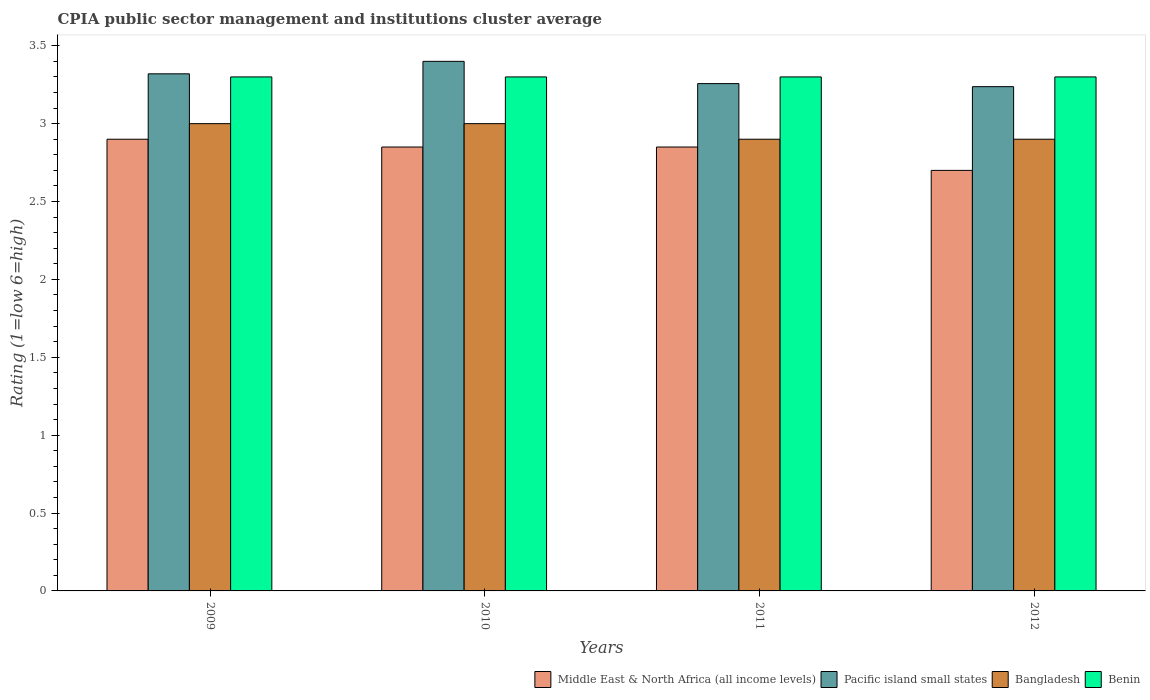How many different coloured bars are there?
Your answer should be compact. 4. How many groups of bars are there?
Your answer should be very brief. 4. Are the number of bars on each tick of the X-axis equal?
Ensure brevity in your answer.  Yes. In how many cases, is the number of bars for a given year not equal to the number of legend labels?
Your answer should be compact. 0. Across all years, what is the minimum CPIA rating in Middle East & North Africa (all income levels)?
Offer a very short reply. 2.7. In which year was the CPIA rating in Middle East & North Africa (all income levels) maximum?
Your answer should be compact. 2009. What is the difference between the CPIA rating in Bangladesh in 2009 and that in 2010?
Keep it short and to the point. 0. What is the difference between the CPIA rating in Bangladesh in 2010 and the CPIA rating in Pacific island small states in 2009?
Offer a very short reply. -0.32. What is the average CPIA rating in Benin per year?
Keep it short and to the point. 3.3. In the year 2011, what is the difference between the CPIA rating in Middle East & North Africa (all income levels) and CPIA rating in Benin?
Offer a very short reply. -0.45. In how many years, is the CPIA rating in Middle East & North Africa (all income levels) greater than 0.30000000000000004?
Provide a succinct answer. 4. What is the ratio of the CPIA rating in Pacific island small states in 2011 to that in 2012?
Make the answer very short. 1.01. What is the difference between the highest and the second highest CPIA rating in Pacific island small states?
Your response must be concise. 0.08. What is the difference between the highest and the lowest CPIA rating in Middle East & North Africa (all income levels)?
Ensure brevity in your answer.  0.2. Is the sum of the CPIA rating in Benin in 2010 and 2012 greater than the maximum CPIA rating in Pacific island small states across all years?
Offer a terse response. Yes. Is it the case that in every year, the sum of the CPIA rating in Benin and CPIA rating in Pacific island small states is greater than the sum of CPIA rating in Bangladesh and CPIA rating in Middle East & North Africa (all income levels)?
Provide a short and direct response. No. What does the 3rd bar from the left in 2009 represents?
Make the answer very short. Bangladesh. What does the 2nd bar from the right in 2011 represents?
Make the answer very short. Bangladesh. How many bars are there?
Your answer should be compact. 16. Are all the bars in the graph horizontal?
Your answer should be very brief. No. What is the difference between two consecutive major ticks on the Y-axis?
Make the answer very short. 0.5. Does the graph contain any zero values?
Offer a very short reply. No. Does the graph contain grids?
Make the answer very short. No. How many legend labels are there?
Your response must be concise. 4. What is the title of the graph?
Make the answer very short. CPIA public sector management and institutions cluster average. What is the Rating (1=low 6=high) in Middle East & North Africa (all income levels) in 2009?
Provide a short and direct response. 2.9. What is the Rating (1=low 6=high) of Pacific island small states in 2009?
Keep it short and to the point. 3.32. What is the Rating (1=low 6=high) in Bangladesh in 2009?
Keep it short and to the point. 3. What is the Rating (1=low 6=high) of Middle East & North Africa (all income levels) in 2010?
Offer a very short reply. 2.85. What is the Rating (1=low 6=high) in Pacific island small states in 2010?
Give a very brief answer. 3.4. What is the Rating (1=low 6=high) of Benin in 2010?
Provide a succinct answer. 3.3. What is the Rating (1=low 6=high) in Middle East & North Africa (all income levels) in 2011?
Offer a very short reply. 2.85. What is the Rating (1=low 6=high) of Pacific island small states in 2011?
Ensure brevity in your answer.  3.26. What is the Rating (1=low 6=high) of Benin in 2011?
Offer a very short reply. 3.3. What is the Rating (1=low 6=high) in Middle East & North Africa (all income levels) in 2012?
Provide a succinct answer. 2.7. What is the Rating (1=low 6=high) in Pacific island small states in 2012?
Make the answer very short. 3.24. What is the Rating (1=low 6=high) of Benin in 2012?
Your answer should be very brief. 3.3. Across all years, what is the maximum Rating (1=low 6=high) of Pacific island small states?
Offer a very short reply. 3.4. Across all years, what is the maximum Rating (1=low 6=high) of Benin?
Ensure brevity in your answer.  3.3. Across all years, what is the minimum Rating (1=low 6=high) of Middle East & North Africa (all income levels)?
Ensure brevity in your answer.  2.7. Across all years, what is the minimum Rating (1=low 6=high) of Pacific island small states?
Your response must be concise. 3.24. Across all years, what is the minimum Rating (1=low 6=high) in Bangladesh?
Your response must be concise. 2.9. What is the total Rating (1=low 6=high) of Middle East & North Africa (all income levels) in the graph?
Ensure brevity in your answer.  11.3. What is the total Rating (1=low 6=high) in Pacific island small states in the graph?
Provide a succinct answer. 13.21. What is the total Rating (1=low 6=high) of Bangladesh in the graph?
Offer a terse response. 11.8. What is the total Rating (1=low 6=high) of Benin in the graph?
Your answer should be compact. 13.2. What is the difference between the Rating (1=low 6=high) in Middle East & North Africa (all income levels) in 2009 and that in 2010?
Provide a succinct answer. 0.05. What is the difference between the Rating (1=low 6=high) of Pacific island small states in 2009 and that in 2010?
Your response must be concise. -0.08. What is the difference between the Rating (1=low 6=high) in Benin in 2009 and that in 2010?
Provide a succinct answer. 0. What is the difference between the Rating (1=low 6=high) of Middle East & North Africa (all income levels) in 2009 and that in 2011?
Ensure brevity in your answer.  0.05. What is the difference between the Rating (1=low 6=high) of Pacific island small states in 2009 and that in 2011?
Your answer should be very brief. 0.06. What is the difference between the Rating (1=low 6=high) in Benin in 2009 and that in 2011?
Make the answer very short. 0. What is the difference between the Rating (1=low 6=high) in Middle East & North Africa (all income levels) in 2009 and that in 2012?
Ensure brevity in your answer.  0.2. What is the difference between the Rating (1=low 6=high) in Pacific island small states in 2009 and that in 2012?
Your answer should be compact. 0.08. What is the difference between the Rating (1=low 6=high) of Bangladesh in 2009 and that in 2012?
Provide a short and direct response. 0.1. What is the difference between the Rating (1=low 6=high) in Middle East & North Africa (all income levels) in 2010 and that in 2011?
Offer a terse response. 0. What is the difference between the Rating (1=low 6=high) of Pacific island small states in 2010 and that in 2011?
Give a very brief answer. 0.14. What is the difference between the Rating (1=low 6=high) of Bangladesh in 2010 and that in 2011?
Make the answer very short. 0.1. What is the difference between the Rating (1=low 6=high) in Middle East & North Africa (all income levels) in 2010 and that in 2012?
Your response must be concise. 0.15. What is the difference between the Rating (1=low 6=high) in Pacific island small states in 2010 and that in 2012?
Provide a succinct answer. 0.16. What is the difference between the Rating (1=low 6=high) in Bangladesh in 2010 and that in 2012?
Give a very brief answer. 0.1. What is the difference between the Rating (1=low 6=high) of Benin in 2010 and that in 2012?
Offer a terse response. 0. What is the difference between the Rating (1=low 6=high) of Pacific island small states in 2011 and that in 2012?
Provide a short and direct response. 0.02. What is the difference between the Rating (1=low 6=high) of Bangladesh in 2011 and that in 2012?
Give a very brief answer. 0. What is the difference between the Rating (1=low 6=high) of Benin in 2011 and that in 2012?
Make the answer very short. 0. What is the difference between the Rating (1=low 6=high) in Middle East & North Africa (all income levels) in 2009 and the Rating (1=low 6=high) in Bangladesh in 2010?
Make the answer very short. -0.1. What is the difference between the Rating (1=low 6=high) of Middle East & North Africa (all income levels) in 2009 and the Rating (1=low 6=high) of Benin in 2010?
Make the answer very short. -0.4. What is the difference between the Rating (1=low 6=high) in Pacific island small states in 2009 and the Rating (1=low 6=high) in Bangladesh in 2010?
Offer a very short reply. 0.32. What is the difference between the Rating (1=low 6=high) in Middle East & North Africa (all income levels) in 2009 and the Rating (1=low 6=high) in Pacific island small states in 2011?
Your answer should be compact. -0.36. What is the difference between the Rating (1=low 6=high) of Middle East & North Africa (all income levels) in 2009 and the Rating (1=low 6=high) of Bangladesh in 2011?
Provide a short and direct response. 0. What is the difference between the Rating (1=low 6=high) of Pacific island small states in 2009 and the Rating (1=low 6=high) of Bangladesh in 2011?
Provide a succinct answer. 0.42. What is the difference between the Rating (1=low 6=high) of Middle East & North Africa (all income levels) in 2009 and the Rating (1=low 6=high) of Pacific island small states in 2012?
Provide a succinct answer. -0.34. What is the difference between the Rating (1=low 6=high) of Middle East & North Africa (all income levels) in 2009 and the Rating (1=low 6=high) of Benin in 2012?
Your answer should be very brief. -0.4. What is the difference between the Rating (1=low 6=high) in Pacific island small states in 2009 and the Rating (1=low 6=high) in Bangladesh in 2012?
Offer a terse response. 0.42. What is the difference between the Rating (1=low 6=high) of Bangladesh in 2009 and the Rating (1=low 6=high) of Benin in 2012?
Provide a short and direct response. -0.3. What is the difference between the Rating (1=low 6=high) in Middle East & North Africa (all income levels) in 2010 and the Rating (1=low 6=high) in Pacific island small states in 2011?
Give a very brief answer. -0.41. What is the difference between the Rating (1=low 6=high) in Middle East & North Africa (all income levels) in 2010 and the Rating (1=low 6=high) in Bangladesh in 2011?
Keep it short and to the point. -0.05. What is the difference between the Rating (1=low 6=high) in Middle East & North Africa (all income levels) in 2010 and the Rating (1=low 6=high) in Benin in 2011?
Provide a short and direct response. -0.45. What is the difference between the Rating (1=low 6=high) in Pacific island small states in 2010 and the Rating (1=low 6=high) in Benin in 2011?
Offer a very short reply. 0.1. What is the difference between the Rating (1=low 6=high) in Middle East & North Africa (all income levels) in 2010 and the Rating (1=low 6=high) in Pacific island small states in 2012?
Your response must be concise. -0.39. What is the difference between the Rating (1=low 6=high) in Middle East & North Africa (all income levels) in 2010 and the Rating (1=low 6=high) in Bangladesh in 2012?
Make the answer very short. -0.05. What is the difference between the Rating (1=low 6=high) in Middle East & North Africa (all income levels) in 2010 and the Rating (1=low 6=high) in Benin in 2012?
Your response must be concise. -0.45. What is the difference between the Rating (1=low 6=high) of Pacific island small states in 2010 and the Rating (1=low 6=high) of Bangladesh in 2012?
Offer a terse response. 0.5. What is the difference between the Rating (1=low 6=high) in Pacific island small states in 2010 and the Rating (1=low 6=high) in Benin in 2012?
Your response must be concise. 0.1. What is the difference between the Rating (1=low 6=high) of Bangladesh in 2010 and the Rating (1=low 6=high) of Benin in 2012?
Your answer should be compact. -0.3. What is the difference between the Rating (1=low 6=high) in Middle East & North Africa (all income levels) in 2011 and the Rating (1=low 6=high) in Pacific island small states in 2012?
Your answer should be very brief. -0.39. What is the difference between the Rating (1=low 6=high) in Middle East & North Africa (all income levels) in 2011 and the Rating (1=low 6=high) in Benin in 2012?
Keep it short and to the point. -0.45. What is the difference between the Rating (1=low 6=high) in Pacific island small states in 2011 and the Rating (1=low 6=high) in Bangladesh in 2012?
Provide a succinct answer. 0.36. What is the difference between the Rating (1=low 6=high) in Pacific island small states in 2011 and the Rating (1=low 6=high) in Benin in 2012?
Your answer should be compact. -0.04. What is the difference between the Rating (1=low 6=high) of Bangladesh in 2011 and the Rating (1=low 6=high) of Benin in 2012?
Give a very brief answer. -0.4. What is the average Rating (1=low 6=high) of Middle East & North Africa (all income levels) per year?
Make the answer very short. 2.83. What is the average Rating (1=low 6=high) in Pacific island small states per year?
Ensure brevity in your answer.  3.3. What is the average Rating (1=low 6=high) in Bangladesh per year?
Ensure brevity in your answer.  2.95. In the year 2009, what is the difference between the Rating (1=low 6=high) of Middle East & North Africa (all income levels) and Rating (1=low 6=high) of Pacific island small states?
Your answer should be compact. -0.42. In the year 2009, what is the difference between the Rating (1=low 6=high) in Middle East & North Africa (all income levels) and Rating (1=low 6=high) in Bangladesh?
Provide a short and direct response. -0.1. In the year 2009, what is the difference between the Rating (1=low 6=high) in Pacific island small states and Rating (1=low 6=high) in Bangladesh?
Your answer should be very brief. 0.32. In the year 2009, what is the difference between the Rating (1=low 6=high) of Bangladesh and Rating (1=low 6=high) of Benin?
Make the answer very short. -0.3. In the year 2010, what is the difference between the Rating (1=low 6=high) of Middle East & North Africa (all income levels) and Rating (1=low 6=high) of Pacific island small states?
Your response must be concise. -0.55. In the year 2010, what is the difference between the Rating (1=low 6=high) in Middle East & North Africa (all income levels) and Rating (1=low 6=high) in Bangladesh?
Your answer should be very brief. -0.15. In the year 2010, what is the difference between the Rating (1=low 6=high) of Middle East & North Africa (all income levels) and Rating (1=low 6=high) of Benin?
Ensure brevity in your answer.  -0.45. In the year 2010, what is the difference between the Rating (1=low 6=high) in Pacific island small states and Rating (1=low 6=high) in Benin?
Offer a terse response. 0.1. In the year 2010, what is the difference between the Rating (1=low 6=high) of Bangladesh and Rating (1=low 6=high) of Benin?
Make the answer very short. -0.3. In the year 2011, what is the difference between the Rating (1=low 6=high) of Middle East & North Africa (all income levels) and Rating (1=low 6=high) of Pacific island small states?
Make the answer very short. -0.41. In the year 2011, what is the difference between the Rating (1=low 6=high) in Middle East & North Africa (all income levels) and Rating (1=low 6=high) in Bangladesh?
Ensure brevity in your answer.  -0.05. In the year 2011, what is the difference between the Rating (1=low 6=high) in Middle East & North Africa (all income levels) and Rating (1=low 6=high) in Benin?
Your answer should be very brief. -0.45. In the year 2011, what is the difference between the Rating (1=low 6=high) in Pacific island small states and Rating (1=low 6=high) in Bangladesh?
Ensure brevity in your answer.  0.36. In the year 2011, what is the difference between the Rating (1=low 6=high) in Pacific island small states and Rating (1=low 6=high) in Benin?
Your answer should be compact. -0.04. In the year 2012, what is the difference between the Rating (1=low 6=high) in Middle East & North Africa (all income levels) and Rating (1=low 6=high) in Pacific island small states?
Your response must be concise. -0.54. In the year 2012, what is the difference between the Rating (1=low 6=high) of Middle East & North Africa (all income levels) and Rating (1=low 6=high) of Bangladesh?
Give a very brief answer. -0.2. In the year 2012, what is the difference between the Rating (1=low 6=high) of Pacific island small states and Rating (1=low 6=high) of Bangladesh?
Provide a short and direct response. 0.34. In the year 2012, what is the difference between the Rating (1=low 6=high) in Pacific island small states and Rating (1=low 6=high) in Benin?
Your answer should be very brief. -0.06. What is the ratio of the Rating (1=low 6=high) of Middle East & North Africa (all income levels) in 2009 to that in 2010?
Make the answer very short. 1.02. What is the ratio of the Rating (1=low 6=high) in Pacific island small states in 2009 to that in 2010?
Make the answer very short. 0.98. What is the ratio of the Rating (1=low 6=high) in Middle East & North Africa (all income levels) in 2009 to that in 2011?
Your answer should be very brief. 1.02. What is the ratio of the Rating (1=low 6=high) of Pacific island small states in 2009 to that in 2011?
Keep it short and to the point. 1.02. What is the ratio of the Rating (1=low 6=high) of Bangladesh in 2009 to that in 2011?
Offer a very short reply. 1.03. What is the ratio of the Rating (1=low 6=high) in Benin in 2009 to that in 2011?
Offer a terse response. 1. What is the ratio of the Rating (1=low 6=high) in Middle East & North Africa (all income levels) in 2009 to that in 2012?
Your response must be concise. 1.07. What is the ratio of the Rating (1=low 6=high) in Pacific island small states in 2009 to that in 2012?
Offer a very short reply. 1.03. What is the ratio of the Rating (1=low 6=high) of Bangladesh in 2009 to that in 2012?
Your answer should be very brief. 1.03. What is the ratio of the Rating (1=low 6=high) of Benin in 2009 to that in 2012?
Give a very brief answer. 1. What is the ratio of the Rating (1=low 6=high) of Middle East & North Africa (all income levels) in 2010 to that in 2011?
Provide a succinct answer. 1. What is the ratio of the Rating (1=low 6=high) of Pacific island small states in 2010 to that in 2011?
Make the answer very short. 1.04. What is the ratio of the Rating (1=low 6=high) in Bangladesh in 2010 to that in 2011?
Offer a very short reply. 1.03. What is the ratio of the Rating (1=low 6=high) of Benin in 2010 to that in 2011?
Your answer should be compact. 1. What is the ratio of the Rating (1=low 6=high) of Middle East & North Africa (all income levels) in 2010 to that in 2012?
Give a very brief answer. 1.06. What is the ratio of the Rating (1=low 6=high) of Pacific island small states in 2010 to that in 2012?
Your answer should be compact. 1.05. What is the ratio of the Rating (1=low 6=high) in Bangladesh in 2010 to that in 2012?
Make the answer very short. 1.03. What is the ratio of the Rating (1=low 6=high) in Middle East & North Africa (all income levels) in 2011 to that in 2012?
Your response must be concise. 1.06. What is the ratio of the Rating (1=low 6=high) in Pacific island small states in 2011 to that in 2012?
Your response must be concise. 1.01. What is the ratio of the Rating (1=low 6=high) in Bangladesh in 2011 to that in 2012?
Make the answer very short. 1. What is the ratio of the Rating (1=low 6=high) in Benin in 2011 to that in 2012?
Provide a succinct answer. 1. What is the difference between the highest and the second highest Rating (1=low 6=high) of Middle East & North Africa (all income levels)?
Offer a very short reply. 0.05. What is the difference between the highest and the second highest Rating (1=low 6=high) of Bangladesh?
Offer a terse response. 0. What is the difference between the highest and the second highest Rating (1=low 6=high) of Benin?
Offer a very short reply. 0. What is the difference between the highest and the lowest Rating (1=low 6=high) of Pacific island small states?
Provide a short and direct response. 0.16. What is the difference between the highest and the lowest Rating (1=low 6=high) of Benin?
Your answer should be compact. 0. 